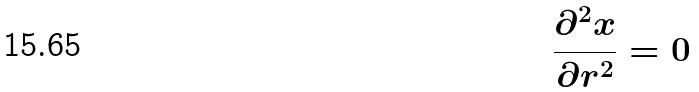Convert formula to latex. <formula><loc_0><loc_0><loc_500><loc_500>\frac { \partial ^ { 2 } x } { \partial r ^ { 2 } } = 0</formula> 